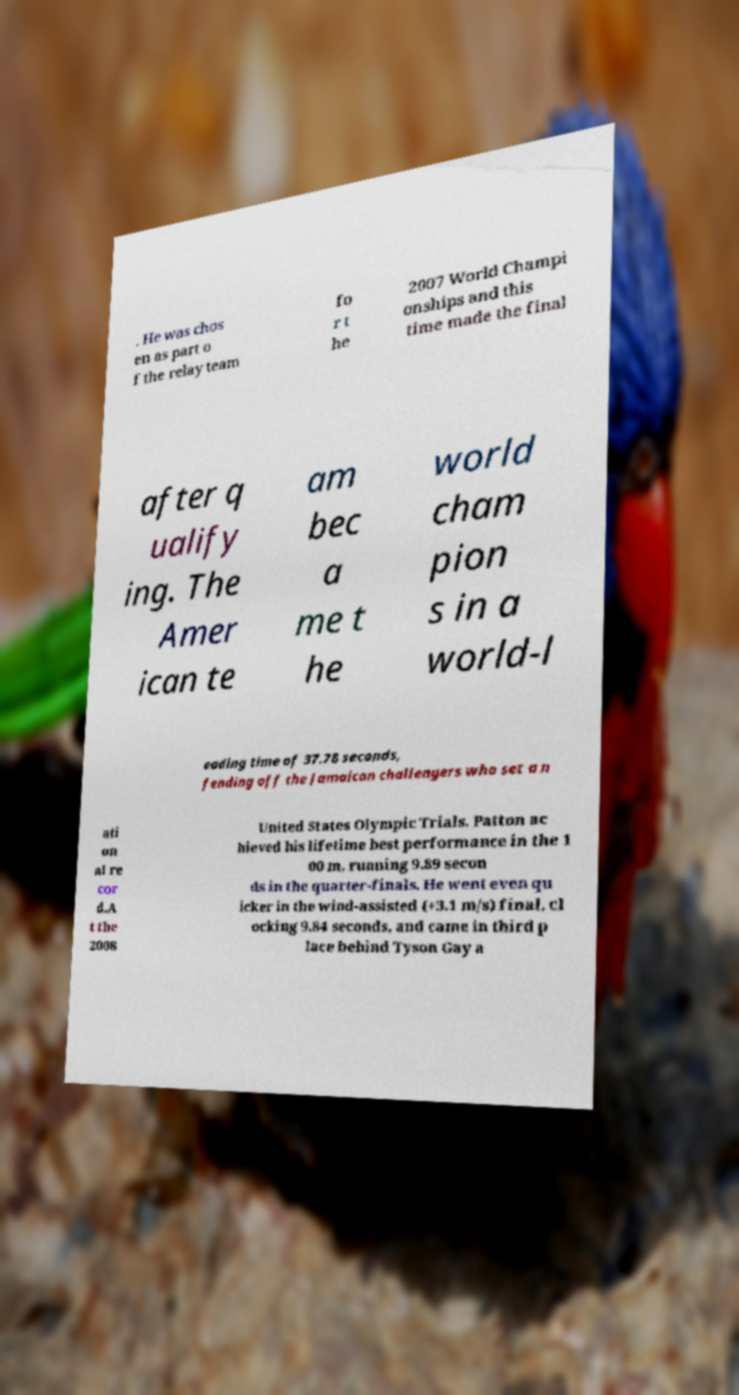I need the written content from this picture converted into text. Can you do that? . He was chos en as part o f the relay team fo r t he 2007 World Champi onships and this time made the final after q ualify ing. The Amer ican te am bec a me t he world cham pion s in a world-l eading time of 37.78 seconds, fending off the Jamaican challengers who set a n ati on al re cor d.A t the 2008 United States Olympic Trials, Patton ac hieved his lifetime best performance in the 1 00 m, running 9.89 secon ds in the quarter-finals. He went even qu icker in the wind-assisted (+3.1 m/s) final, cl ocking 9.84 seconds, and came in third p lace behind Tyson Gay a 